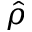<formula> <loc_0><loc_0><loc_500><loc_500>\hat { \rho }</formula> 